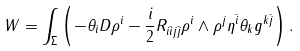Convert formula to latex. <formula><loc_0><loc_0><loc_500><loc_500>W & = \int _ { \Sigma } \left ( - \theta _ { i } D \rho ^ { i } - \frac { i } { 2 } R _ { i \bar { i } j \bar { j } } \rho ^ { i } \wedge \rho ^ { j } \eta ^ { \bar { i } } \theta _ { k } g ^ { k \bar { j } } \right ) .</formula> 